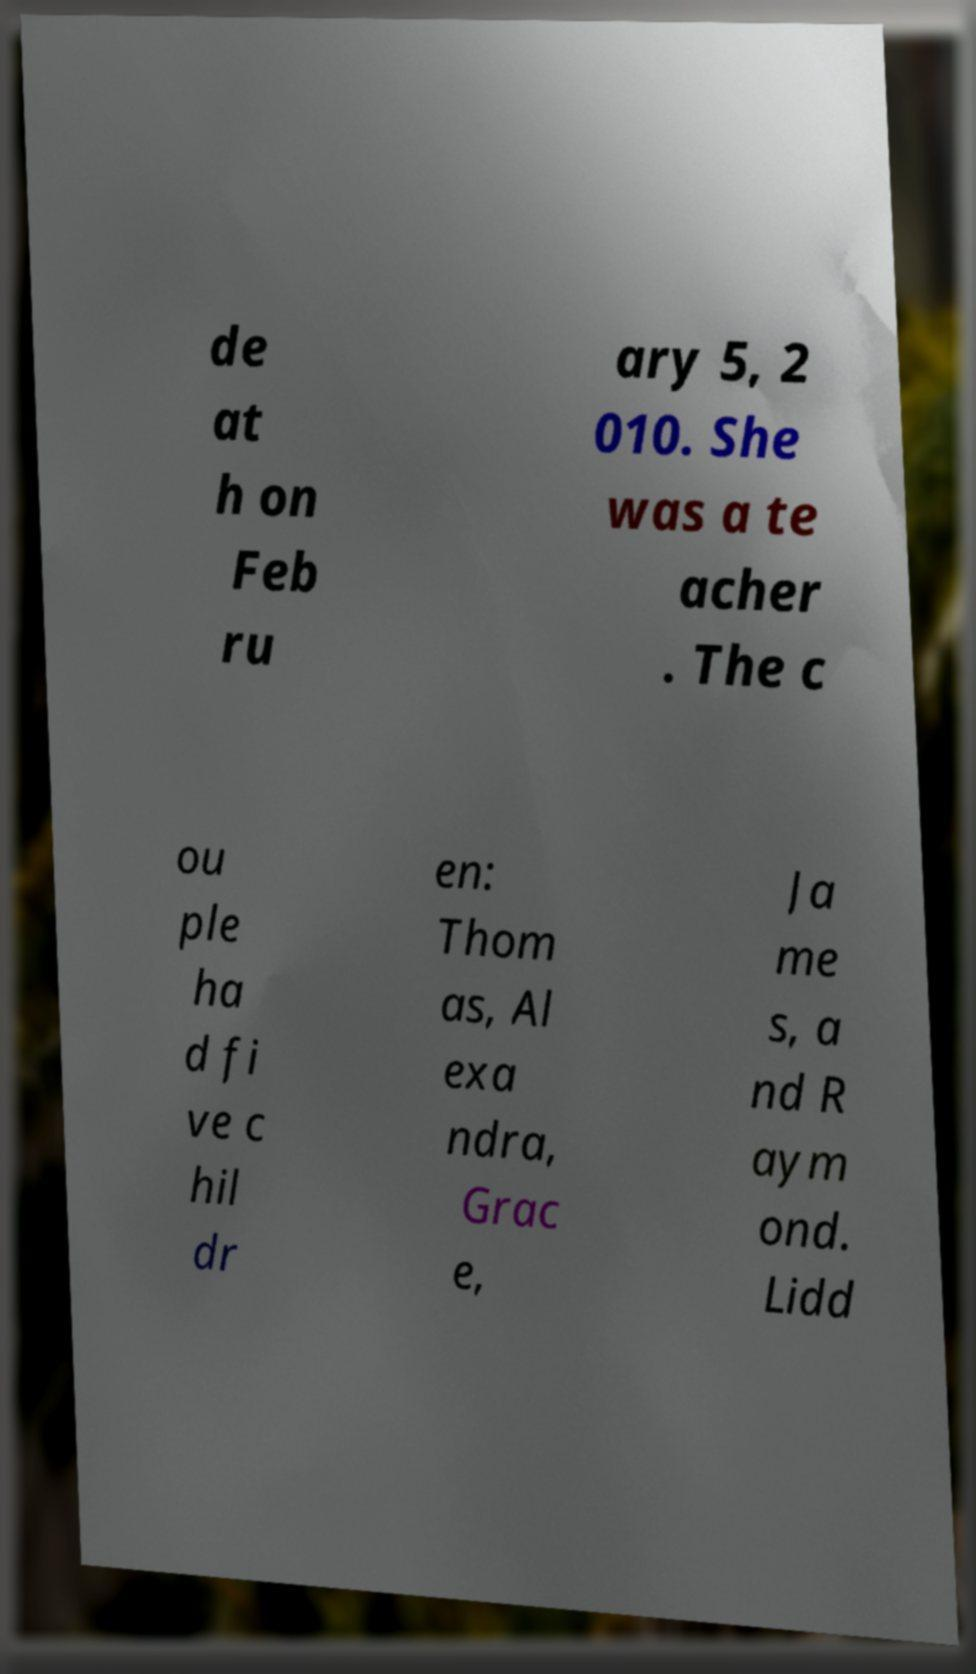What messages or text are displayed in this image? I need them in a readable, typed format. de at h on Feb ru ary 5, 2 010. She was a te acher . The c ou ple ha d fi ve c hil dr en: Thom as, Al exa ndra, Grac e, Ja me s, a nd R aym ond. Lidd 